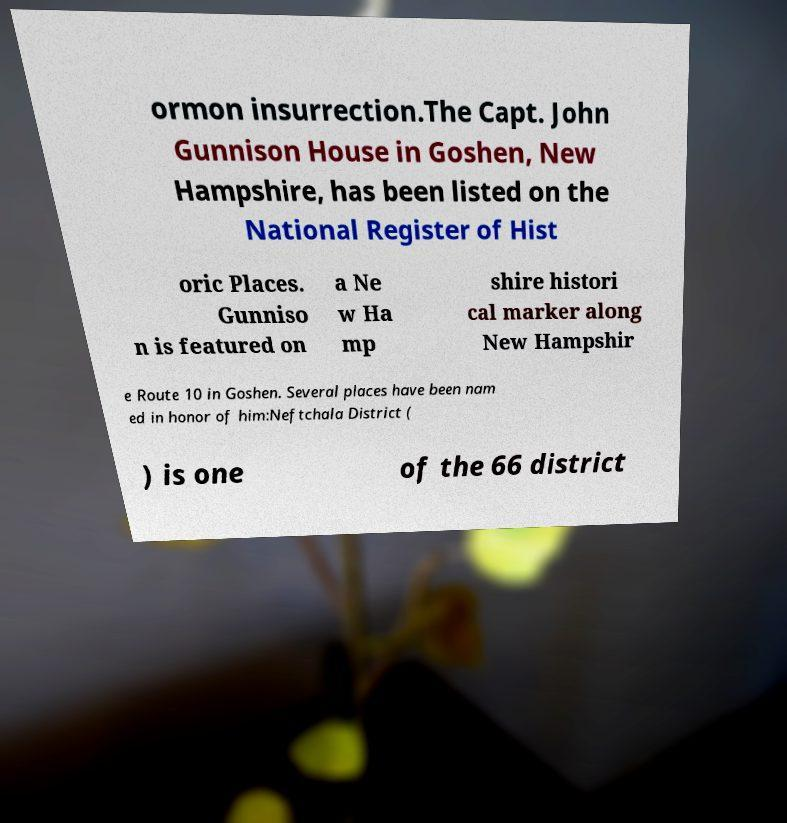Please read and relay the text visible in this image. What does it say? ormon insurrection.The Capt. John Gunnison House in Goshen, New Hampshire, has been listed on the National Register of Hist oric Places. Gunniso n is featured on a Ne w Ha mp shire histori cal marker along New Hampshir e Route 10 in Goshen. Several places have been nam ed in honor of him:Neftchala District ( ) is one of the 66 district 